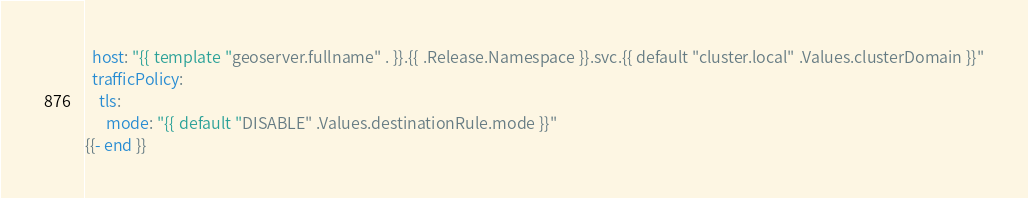<code> <loc_0><loc_0><loc_500><loc_500><_YAML_>  host: "{{ template "geoserver.fullname" . }}.{{ .Release.Namespace }}.svc.{{ default "cluster.local" .Values.clusterDomain }}"
  trafficPolicy:
    tls:
      mode: "{{ default "DISABLE" .Values.destinationRule.mode }}"
{{- end }}
</code> 